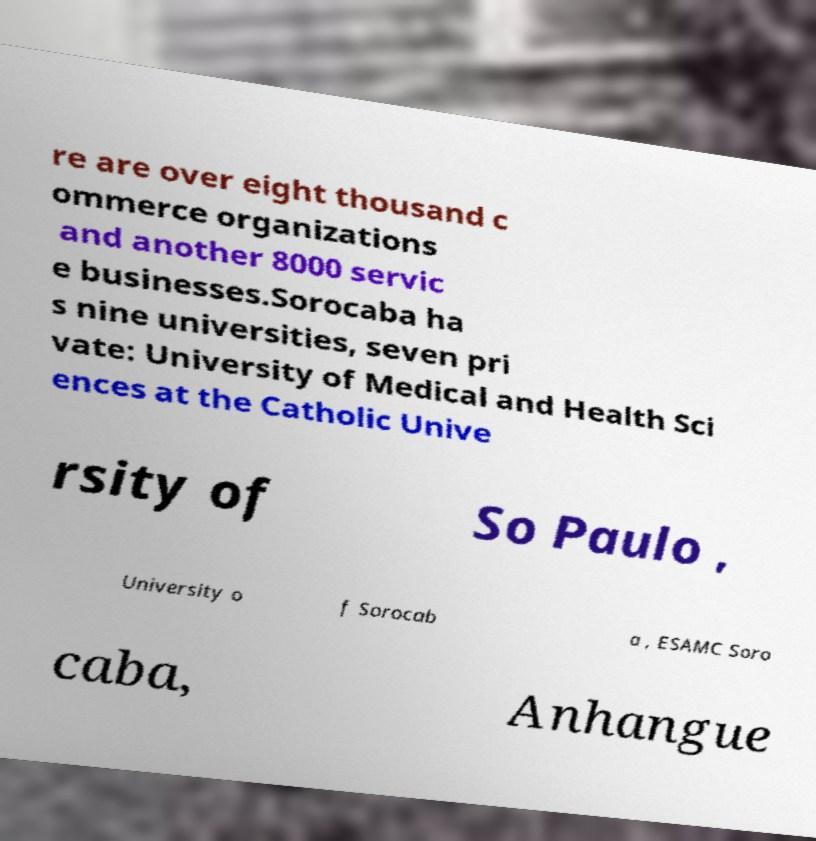For documentation purposes, I need the text within this image transcribed. Could you provide that? re are over eight thousand c ommerce organizations and another 8000 servic e businesses.Sorocaba ha s nine universities, seven pri vate: University of Medical and Health Sci ences at the Catholic Unive rsity of So Paulo , University o f Sorocab a , ESAMC Soro caba, Anhangue 